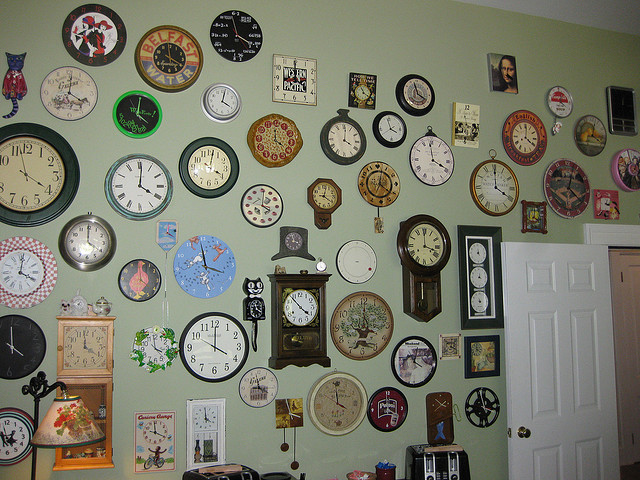What themes can you see among the clocks displayed? The clocks display a variety of themes including traditional floral patterns, modern artsy designs, and novelty shapes like animals and historical figures, reflecting a wide range of tastes and interests. 